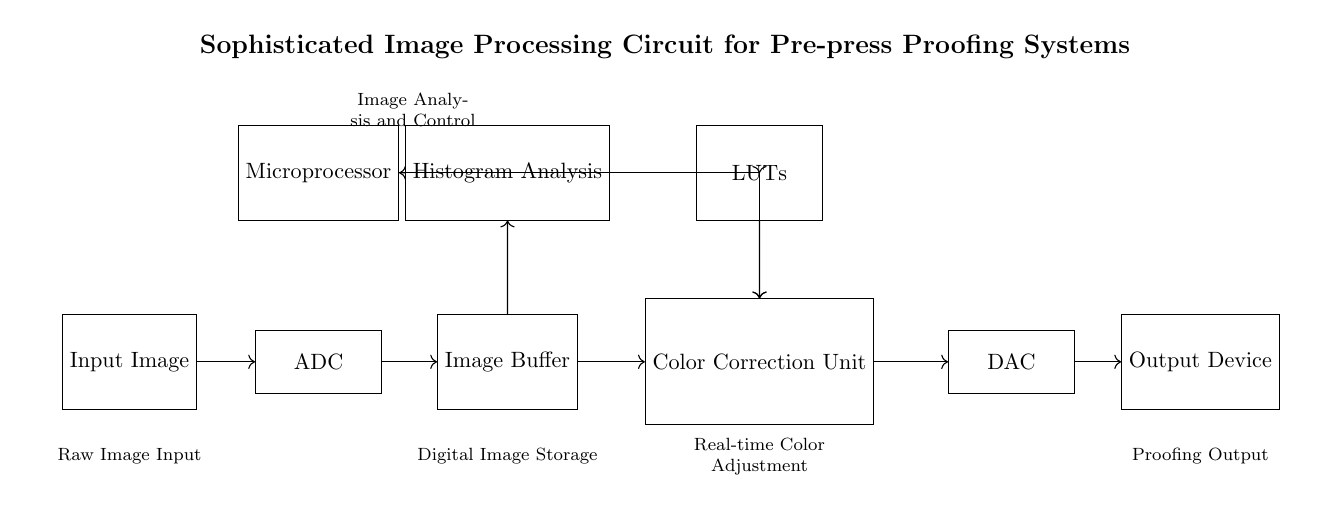What is the first component in the circuit? The first component in the circuit is the Input Image, which serves as the raw data for the image processing task. This component is depicted on the far left of the circuit diagram.
Answer: Input Image How many components are involved in color correction? Color correction is conducted in the Color Correction Unit, which has connections from the Microprocessor and Lookup Tables. Additionally, it is connected to the DAC for output. This unit, therefore, has a total of three components that are directly involved in color correction.
Answer: Three What is the purpose of the Histogram Analysis? The Histogram Analysis serves to evaluate the distribution of pixel values in the image buffer, allowing the system to adjust the color parameters based on the image characteristics. This helps in precision color correction.
Answer: Evaluate distribution What component follows the Image Buffer? The component that follows the Image Buffer in the circuit is the Color Correction Unit. The connections indicate that the processed image data from the buffer moves directly to this unit for adjustments.
Answer: Color Correction Unit Which component is responsible for the final output? The final output is handled by the Output Device, as indicated by the connections leading from the DAC to this component after processing. This ensures that the corrected image is displayed or printed as intended.
Answer: Output Device How does the Microprocessor interact with the Lookup Tables? The Microprocessor interacts with the Lookup Tables through a two-way connection, allowing it to gather analytical data from the Histogram Analysis while simultaneously sending control signals for color corrections based on the processed data.
Answer: Two-way connection What is stored in the Image Buffer? The Image Buffer stores the digital image data after it has been converted by the ADC and before it undergoes color correction. This function is critical as it allows for temporary storage of the data for processing.
Answer: Digital image data 